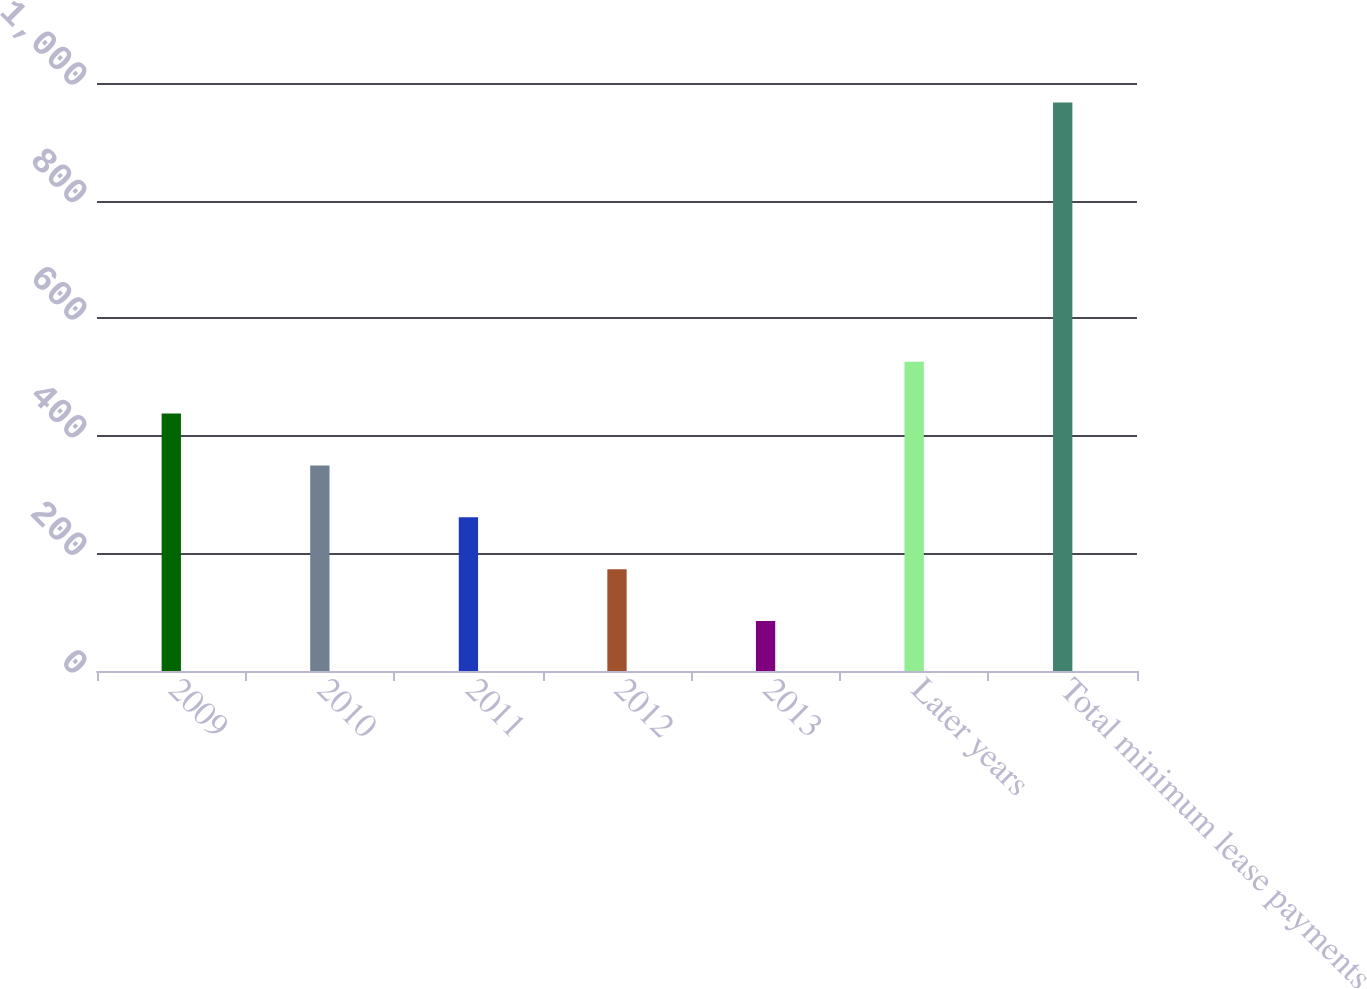Convert chart. <chart><loc_0><loc_0><loc_500><loc_500><bar_chart><fcel>2009<fcel>2010<fcel>2011<fcel>2012<fcel>2013<fcel>Later years<fcel>Total minimum lease payments<nl><fcel>437.8<fcel>349.6<fcel>261.4<fcel>173.2<fcel>85<fcel>526<fcel>967<nl></chart> 